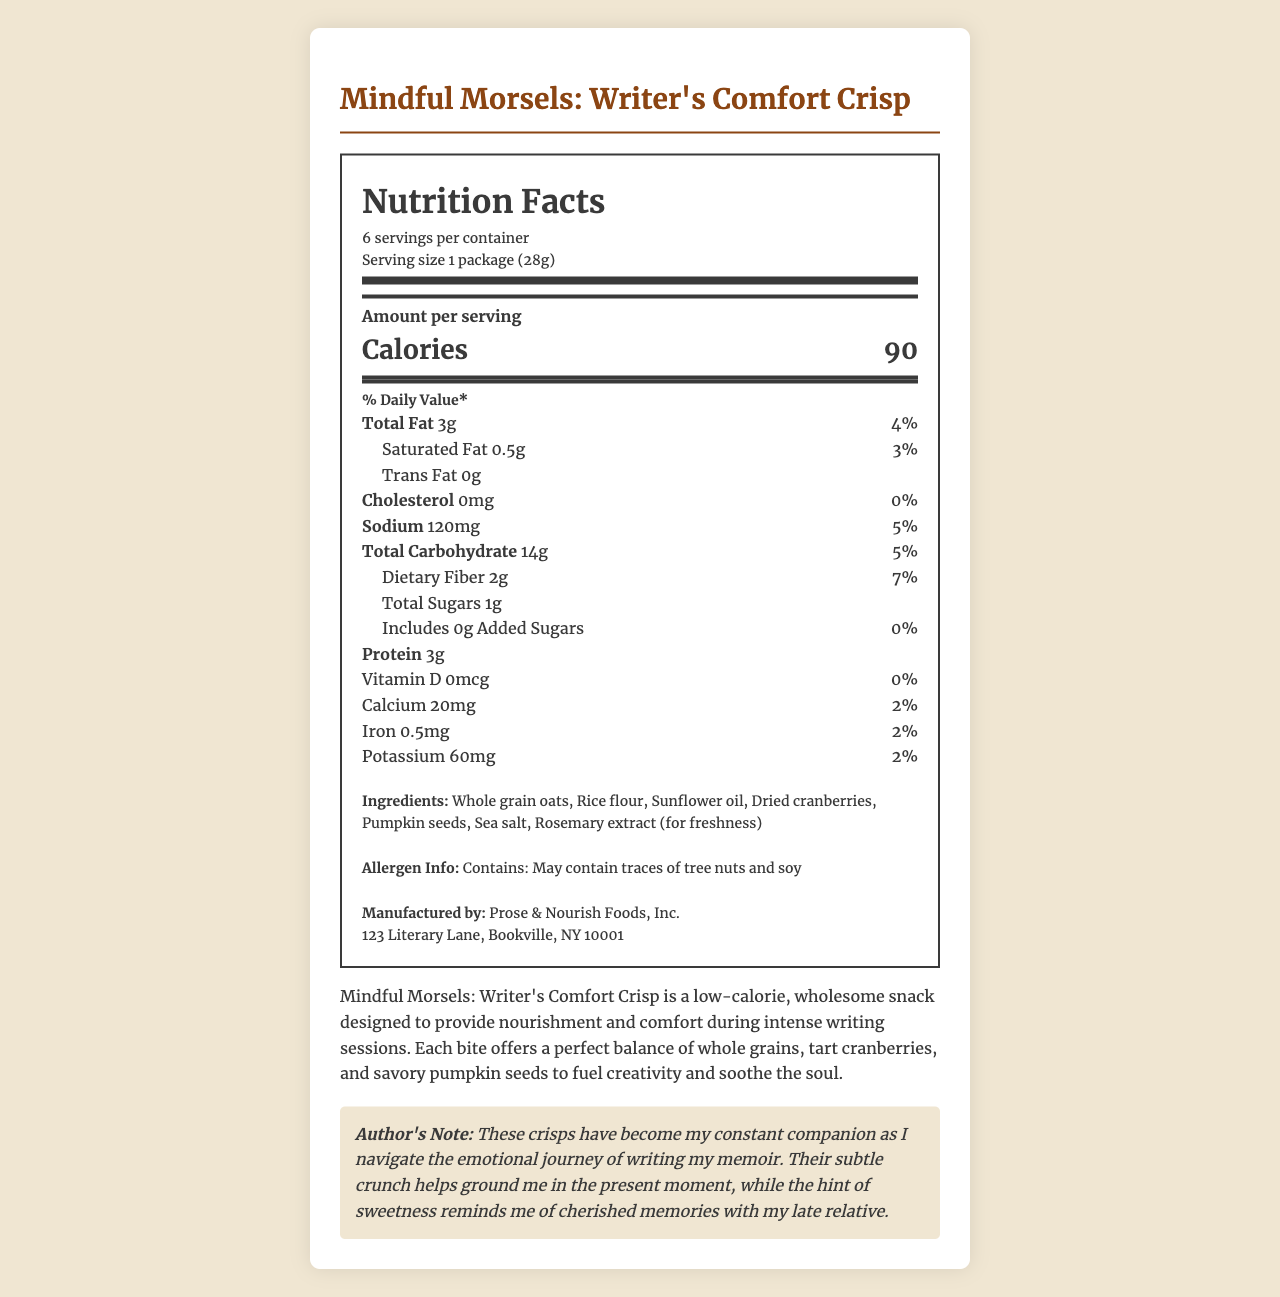how many servings are in the container? The label states that there are 6 servings per container.
Answer: 6 what is the serving size? The serving size is listed as "1 package (28g)" on the label.
Answer: 1 package (28g) how many calories are in one serving? The label indicates that each serving contains 90 calories.
Answer: 90 how much dietary fiber does one serving contain? The dietary fiber content per serving is 2g as shown on the label.
Answer: 2g which ingredient is used for freshness? According to the ingredients list, rosemary extract is used for freshness.
Answer: Rosemary extract what percentage of the daily value of calcium does one serving provide? A. 0% B. 2% C. 5% The label indicates that one serving provides 2% of the daily value for calcium.
Answer: B which nutrient has the highest daily value percentage? A. Total Fat B. Sodium C. Dietary Fiber D. Potassium Dietary fiber has the highest daily value percentage at 7%.
Answer: C is there any trans fat in the product? The label indicates that there are 0g of trans fat in the product.
Answer: No describe the main idea of the document. The document is a detailed presentation of the nutritional information and ingredients of a specific snack product, including an author's note that personalizes the product's significance.
Answer: The document provides the nutrition facts for "Mindful Morsels: Writer's Comfort Crisp," a low-calorie snack designed to offer nourishment and comfort during writing sessions. It includes detailed information about serving size, calories, nutrients, ingredients, and the author's note on how the product helps in writing their memoir. how much protein is in one serving? The label indicates that there are 3g of protein per serving.
Answer: 3g who manufactures this product? The manufacturer is listed as Prose & Nourish Foods, Inc. on the label.
Answer: Prose & Nourish Foods, Inc. what is the sodium content per serving? The label indicates that each serving has a sodium content of 120mg.
Answer: 120mg what is the daily value percentage for added sugars? The daily value percentage for added sugars is 0% as shown on the label.
Answer: 0% can you tell if the product is gluten-free? The label does not provide information regarding whether the product is gluten-free.
Answer: I don't know what is the author's note about? The author's note describes the emotional significance of the snack and how it aids the author during the writing process.
Answer: The author notes that "Mindful Morsels: Writer's Comfort Crisp" helps them stay grounded and comforted during the emotional journey of writing their memoir, especially reminding them of cherished memories with their late relative. 